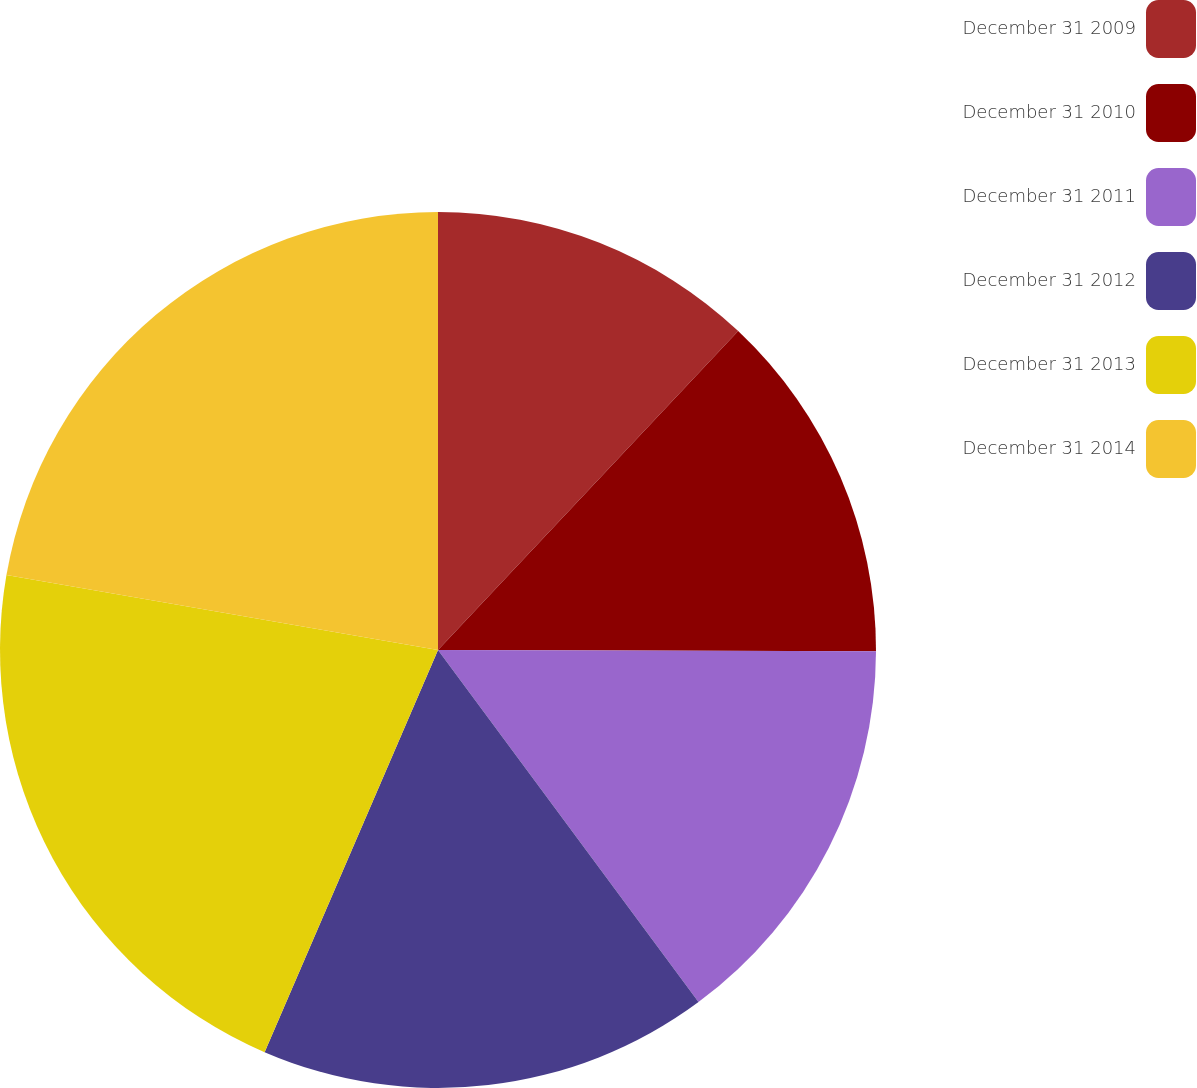Convert chart. <chart><loc_0><loc_0><loc_500><loc_500><pie_chart><fcel>December 31 2009<fcel>December 31 2010<fcel>December 31 2011<fcel>December 31 2012<fcel>December 31 2013<fcel>December 31 2014<nl><fcel>12.02%<fcel>13.03%<fcel>14.82%<fcel>16.62%<fcel>21.26%<fcel>22.27%<nl></chart> 